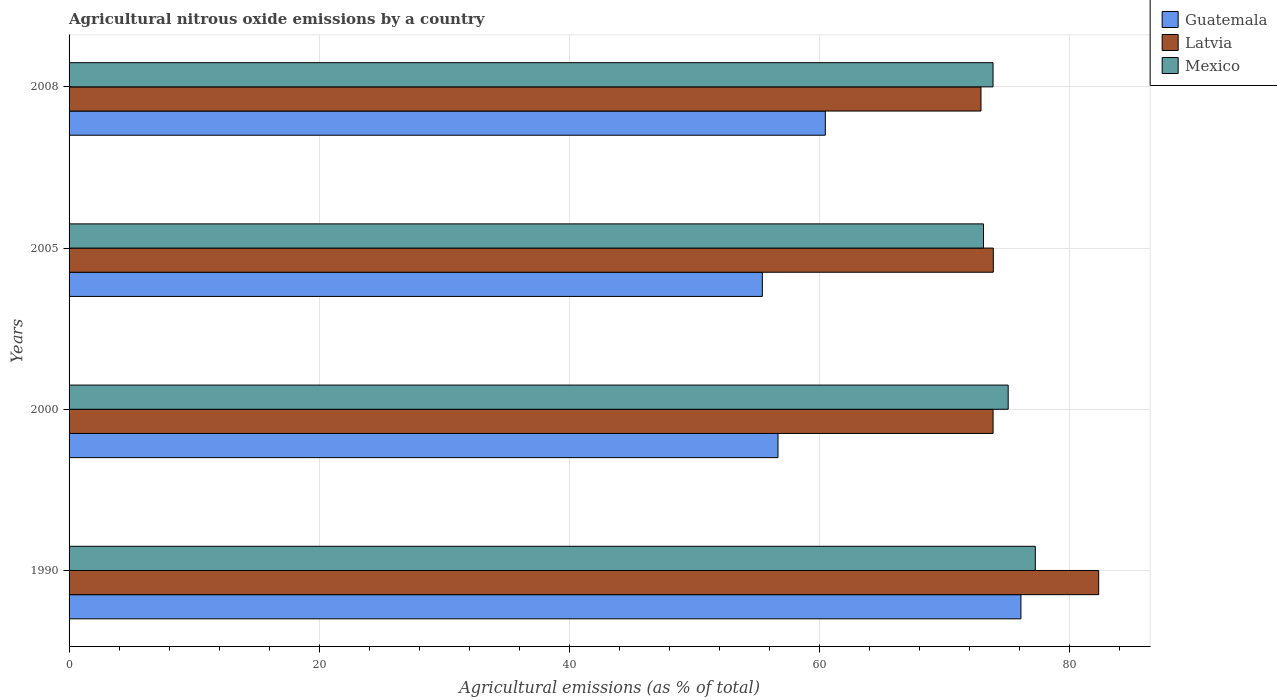How many different coloured bars are there?
Offer a very short reply. 3. How many groups of bars are there?
Offer a terse response. 4. Are the number of bars per tick equal to the number of legend labels?
Offer a very short reply. Yes. Are the number of bars on each tick of the Y-axis equal?
Provide a short and direct response. Yes. How many bars are there on the 2nd tick from the bottom?
Your answer should be compact. 3. What is the label of the 2nd group of bars from the top?
Offer a terse response. 2005. In how many cases, is the number of bars for a given year not equal to the number of legend labels?
Provide a short and direct response. 0. What is the amount of agricultural nitrous oxide emitted in Mexico in 1990?
Your response must be concise. 77.3. Across all years, what is the maximum amount of agricultural nitrous oxide emitted in Latvia?
Your response must be concise. 82.37. Across all years, what is the minimum amount of agricultural nitrous oxide emitted in Mexico?
Keep it short and to the point. 73.16. In which year was the amount of agricultural nitrous oxide emitted in Mexico maximum?
Ensure brevity in your answer.  1990. What is the total amount of agricultural nitrous oxide emitted in Guatemala in the graph?
Provide a short and direct response. 248.84. What is the difference between the amount of agricultural nitrous oxide emitted in Latvia in 2005 and that in 2008?
Make the answer very short. 0.99. What is the difference between the amount of agricultural nitrous oxide emitted in Mexico in 2005 and the amount of agricultural nitrous oxide emitted in Latvia in 2008?
Provide a short and direct response. 0.2. What is the average amount of agricultural nitrous oxide emitted in Mexico per year?
Make the answer very short. 74.88. In the year 2005, what is the difference between the amount of agricultural nitrous oxide emitted in Guatemala and amount of agricultural nitrous oxide emitted in Mexico?
Give a very brief answer. -17.69. In how many years, is the amount of agricultural nitrous oxide emitted in Guatemala greater than 4 %?
Provide a short and direct response. 4. What is the ratio of the amount of agricultural nitrous oxide emitted in Latvia in 1990 to that in 2000?
Your response must be concise. 1.11. Is the difference between the amount of agricultural nitrous oxide emitted in Guatemala in 2000 and 2008 greater than the difference between the amount of agricultural nitrous oxide emitted in Mexico in 2000 and 2008?
Make the answer very short. No. What is the difference between the highest and the second highest amount of agricultural nitrous oxide emitted in Mexico?
Make the answer very short. 2.17. What is the difference between the highest and the lowest amount of agricultural nitrous oxide emitted in Mexico?
Ensure brevity in your answer.  4.15. Is the sum of the amount of agricultural nitrous oxide emitted in Mexico in 1990 and 2008 greater than the maximum amount of agricultural nitrous oxide emitted in Latvia across all years?
Provide a succinct answer. Yes. What does the 1st bar from the top in 2000 represents?
Offer a very short reply. Mexico. Is it the case that in every year, the sum of the amount of agricultural nitrous oxide emitted in Guatemala and amount of agricultural nitrous oxide emitted in Latvia is greater than the amount of agricultural nitrous oxide emitted in Mexico?
Give a very brief answer. Yes. How many bars are there?
Keep it short and to the point. 12. How many years are there in the graph?
Your answer should be compact. 4. What is the difference between two consecutive major ticks on the X-axis?
Your answer should be very brief. 20. Are the values on the major ticks of X-axis written in scientific E-notation?
Your response must be concise. No. Where does the legend appear in the graph?
Keep it short and to the point. Top right. What is the title of the graph?
Keep it short and to the point. Agricultural nitrous oxide emissions by a country. Does "Ghana" appear as one of the legend labels in the graph?
Your response must be concise. No. What is the label or title of the X-axis?
Keep it short and to the point. Agricultural emissions (as % of total). What is the Agricultural emissions (as % of total) of Guatemala in 1990?
Your answer should be compact. 76.15. What is the Agricultural emissions (as % of total) of Latvia in 1990?
Offer a terse response. 82.37. What is the Agricultural emissions (as % of total) of Mexico in 1990?
Make the answer very short. 77.3. What is the Agricultural emissions (as % of total) in Guatemala in 2000?
Ensure brevity in your answer.  56.72. What is the Agricultural emissions (as % of total) in Latvia in 2000?
Ensure brevity in your answer.  73.93. What is the Agricultural emissions (as % of total) of Mexico in 2000?
Give a very brief answer. 75.14. What is the Agricultural emissions (as % of total) in Guatemala in 2005?
Your answer should be very brief. 55.47. What is the Agricultural emissions (as % of total) in Latvia in 2005?
Your response must be concise. 73.94. What is the Agricultural emissions (as % of total) of Mexico in 2005?
Offer a terse response. 73.16. What is the Agricultural emissions (as % of total) of Guatemala in 2008?
Provide a succinct answer. 60.5. What is the Agricultural emissions (as % of total) in Latvia in 2008?
Provide a short and direct response. 72.96. What is the Agricultural emissions (as % of total) of Mexico in 2008?
Keep it short and to the point. 73.92. Across all years, what is the maximum Agricultural emissions (as % of total) of Guatemala?
Provide a succinct answer. 76.15. Across all years, what is the maximum Agricultural emissions (as % of total) in Latvia?
Your answer should be very brief. 82.37. Across all years, what is the maximum Agricultural emissions (as % of total) in Mexico?
Provide a short and direct response. 77.3. Across all years, what is the minimum Agricultural emissions (as % of total) in Guatemala?
Your answer should be very brief. 55.47. Across all years, what is the minimum Agricultural emissions (as % of total) in Latvia?
Ensure brevity in your answer.  72.96. Across all years, what is the minimum Agricultural emissions (as % of total) in Mexico?
Offer a terse response. 73.16. What is the total Agricultural emissions (as % of total) of Guatemala in the graph?
Ensure brevity in your answer.  248.84. What is the total Agricultural emissions (as % of total) of Latvia in the graph?
Provide a short and direct response. 303.2. What is the total Agricultural emissions (as % of total) in Mexico in the graph?
Offer a terse response. 299.52. What is the difference between the Agricultural emissions (as % of total) in Guatemala in 1990 and that in 2000?
Give a very brief answer. 19.43. What is the difference between the Agricultural emissions (as % of total) in Latvia in 1990 and that in 2000?
Your response must be concise. 8.45. What is the difference between the Agricultural emissions (as % of total) in Mexico in 1990 and that in 2000?
Offer a terse response. 2.17. What is the difference between the Agricultural emissions (as % of total) of Guatemala in 1990 and that in 2005?
Your response must be concise. 20.69. What is the difference between the Agricultural emissions (as % of total) in Latvia in 1990 and that in 2005?
Offer a very short reply. 8.43. What is the difference between the Agricultural emissions (as % of total) of Mexico in 1990 and that in 2005?
Ensure brevity in your answer.  4.15. What is the difference between the Agricultural emissions (as % of total) in Guatemala in 1990 and that in 2008?
Your answer should be compact. 15.65. What is the difference between the Agricultural emissions (as % of total) of Latvia in 1990 and that in 2008?
Provide a succinct answer. 9.42. What is the difference between the Agricultural emissions (as % of total) of Mexico in 1990 and that in 2008?
Ensure brevity in your answer.  3.38. What is the difference between the Agricultural emissions (as % of total) in Guatemala in 2000 and that in 2005?
Keep it short and to the point. 1.25. What is the difference between the Agricultural emissions (as % of total) of Latvia in 2000 and that in 2005?
Offer a very short reply. -0.02. What is the difference between the Agricultural emissions (as % of total) in Mexico in 2000 and that in 2005?
Provide a succinct answer. 1.98. What is the difference between the Agricultural emissions (as % of total) in Guatemala in 2000 and that in 2008?
Provide a succinct answer. -3.78. What is the difference between the Agricultural emissions (as % of total) in Latvia in 2000 and that in 2008?
Your response must be concise. 0.97. What is the difference between the Agricultural emissions (as % of total) in Mexico in 2000 and that in 2008?
Your response must be concise. 1.21. What is the difference between the Agricultural emissions (as % of total) of Guatemala in 2005 and that in 2008?
Keep it short and to the point. -5.04. What is the difference between the Agricultural emissions (as % of total) of Latvia in 2005 and that in 2008?
Keep it short and to the point. 0.99. What is the difference between the Agricultural emissions (as % of total) of Mexico in 2005 and that in 2008?
Your answer should be compact. -0.76. What is the difference between the Agricultural emissions (as % of total) of Guatemala in 1990 and the Agricultural emissions (as % of total) of Latvia in 2000?
Give a very brief answer. 2.23. What is the difference between the Agricultural emissions (as % of total) of Guatemala in 1990 and the Agricultural emissions (as % of total) of Mexico in 2000?
Provide a short and direct response. 1.02. What is the difference between the Agricultural emissions (as % of total) of Latvia in 1990 and the Agricultural emissions (as % of total) of Mexico in 2000?
Provide a short and direct response. 7.24. What is the difference between the Agricultural emissions (as % of total) in Guatemala in 1990 and the Agricultural emissions (as % of total) in Latvia in 2005?
Ensure brevity in your answer.  2.21. What is the difference between the Agricultural emissions (as % of total) in Guatemala in 1990 and the Agricultural emissions (as % of total) in Mexico in 2005?
Your response must be concise. 3. What is the difference between the Agricultural emissions (as % of total) of Latvia in 1990 and the Agricultural emissions (as % of total) of Mexico in 2005?
Make the answer very short. 9.21. What is the difference between the Agricultural emissions (as % of total) in Guatemala in 1990 and the Agricultural emissions (as % of total) in Latvia in 2008?
Make the answer very short. 3.2. What is the difference between the Agricultural emissions (as % of total) in Guatemala in 1990 and the Agricultural emissions (as % of total) in Mexico in 2008?
Your answer should be compact. 2.23. What is the difference between the Agricultural emissions (as % of total) in Latvia in 1990 and the Agricultural emissions (as % of total) in Mexico in 2008?
Keep it short and to the point. 8.45. What is the difference between the Agricultural emissions (as % of total) of Guatemala in 2000 and the Agricultural emissions (as % of total) of Latvia in 2005?
Provide a short and direct response. -17.23. What is the difference between the Agricultural emissions (as % of total) in Guatemala in 2000 and the Agricultural emissions (as % of total) in Mexico in 2005?
Provide a short and direct response. -16.44. What is the difference between the Agricultural emissions (as % of total) in Latvia in 2000 and the Agricultural emissions (as % of total) in Mexico in 2005?
Ensure brevity in your answer.  0.77. What is the difference between the Agricultural emissions (as % of total) in Guatemala in 2000 and the Agricultural emissions (as % of total) in Latvia in 2008?
Make the answer very short. -16.24. What is the difference between the Agricultural emissions (as % of total) of Guatemala in 2000 and the Agricultural emissions (as % of total) of Mexico in 2008?
Make the answer very short. -17.2. What is the difference between the Agricultural emissions (as % of total) in Latvia in 2000 and the Agricultural emissions (as % of total) in Mexico in 2008?
Provide a succinct answer. 0. What is the difference between the Agricultural emissions (as % of total) of Guatemala in 2005 and the Agricultural emissions (as % of total) of Latvia in 2008?
Give a very brief answer. -17.49. What is the difference between the Agricultural emissions (as % of total) of Guatemala in 2005 and the Agricultural emissions (as % of total) of Mexico in 2008?
Offer a very short reply. -18.46. What is the difference between the Agricultural emissions (as % of total) of Latvia in 2005 and the Agricultural emissions (as % of total) of Mexico in 2008?
Ensure brevity in your answer.  0.02. What is the average Agricultural emissions (as % of total) in Guatemala per year?
Your answer should be very brief. 62.21. What is the average Agricultural emissions (as % of total) in Latvia per year?
Ensure brevity in your answer.  75.8. What is the average Agricultural emissions (as % of total) in Mexico per year?
Keep it short and to the point. 74.88. In the year 1990, what is the difference between the Agricultural emissions (as % of total) in Guatemala and Agricultural emissions (as % of total) in Latvia?
Provide a succinct answer. -6.22. In the year 1990, what is the difference between the Agricultural emissions (as % of total) in Guatemala and Agricultural emissions (as % of total) in Mexico?
Offer a terse response. -1.15. In the year 1990, what is the difference between the Agricultural emissions (as % of total) of Latvia and Agricultural emissions (as % of total) of Mexico?
Provide a short and direct response. 5.07. In the year 2000, what is the difference between the Agricultural emissions (as % of total) in Guatemala and Agricultural emissions (as % of total) in Latvia?
Your answer should be compact. -17.21. In the year 2000, what is the difference between the Agricultural emissions (as % of total) in Guatemala and Agricultural emissions (as % of total) in Mexico?
Keep it short and to the point. -18.42. In the year 2000, what is the difference between the Agricultural emissions (as % of total) in Latvia and Agricultural emissions (as % of total) in Mexico?
Your response must be concise. -1.21. In the year 2005, what is the difference between the Agricultural emissions (as % of total) in Guatemala and Agricultural emissions (as % of total) in Latvia?
Offer a terse response. -18.48. In the year 2005, what is the difference between the Agricultural emissions (as % of total) in Guatemala and Agricultural emissions (as % of total) in Mexico?
Provide a succinct answer. -17.69. In the year 2005, what is the difference between the Agricultural emissions (as % of total) in Latvia and Agricultural emissions (as % of total) in Mexico?
Your answer should be very brief. 0.79. In the year 2008, what is the difference between the Agricultural emissions (as % of total) of Guatemala and Agricultural emissions (as % of total) of Latvia?
Offer a terse response. -12.45. In the year 2008, what is the difference between the Agricultural emissions (as % of total) of Guatemala and Agricultural emissions (as % of total) of Mexico?
Your answer should be compact. -13.42. In the year 2008, what is the difference between the Agricultural emissions (as % of total) in Latvia and Agricultural emissions (as % of total) in Mexico?
Your answer should be compact. -0.96. What is the ratio of the Agricultural emissions (as % of total) of Guatemala in 1990 to that in 2000?
Offer a terse response. 1.34. What is the ratio of the Agricultural emissions (as % of total) of Latvia in 1990 to that in 2000?
Your answer should be compact. 1.11. What is the ratio of the Agricultural emissions (as % of total) of Mexico in 1990 to that in 2000?
Your answer should be compact. 1.03. What is the ratio of the Agricultural emissions (as % of total) in Guatemala in 1990 to that in 2005?
Offer a terse response. 1.37. What is the ratio of the Agricultural emissions (as % of total) of Latvia in 1990 to that in 2005?
Provide a short and direct response. 1.11. What is the ratio of the Agricultural emissions (as % of total) of Mexico in 1990 to that in 2005?
Your response must be concise. 1.06. What is the ratio of the Agricultural emissions (as % of total) in Guatemala in 1990 to that in 2008?
Provide a succinct answer. 1.26. What is the ratio of the Agricultural emissions (as % of total) in Latvia in 1990 to that in 2008?
Your answer should be compact. 1.13. What is the ratio of the Agricultural emissions (as % of total) of Mexico in 1990 to that in 2008?
Keep it short and to the point. 1.05. What is the ratio of the Agricultural emissions (as % of total) of Guatemala in 2000 to that in 2005?
Provide a succinct answer. 1.02. What is the ratio of the Agricultural emissions (as % of total) of Latvia in 2000 to that in 2005?
Offer a terse response. 1. What is the ratio of the Agricultural emissions (as % of total) of Latvia in 2000 to that in 2008?
Ensure brevity in your answer.  1.01. What is the ratio of the Agricultural emissions (as % of total) in Mexico in 2000 to that in 2008?
Offer a terse response. 1.02. What is the ratio of the Agricultural emissions (as % of total) of Latvia in 2005 to that in 2008?
Your answer should be compact. 1.01. What is the difference between the highest and the second highest Agricultural emissions (as % of total) of Guatemala?
Provide a short and direct response. 15.65. What is the difference between the highest and the second highest Agricultural emissions (as % of total) of Latvia?
Ensure brevity in your answer.  8.43. What is the difference between the highest and the second highest Agricultural emissions (as % of total) of Mexico?
Give a very brief answer. 2.17. What is the difference between the highest and the lowest Agricultural emissions (as % of total) of Guatemala?
Provide a short and direct response. 20.69. What is the difference between the highest and the lowest Agricultural emissions (as % of total) of Latvia?
Provide a succinct answer. 9.42. What is the difference between the highest and the lowest Agricultural emissions (as % of total) in Mexico?
Make the answer very short. 4.15. 